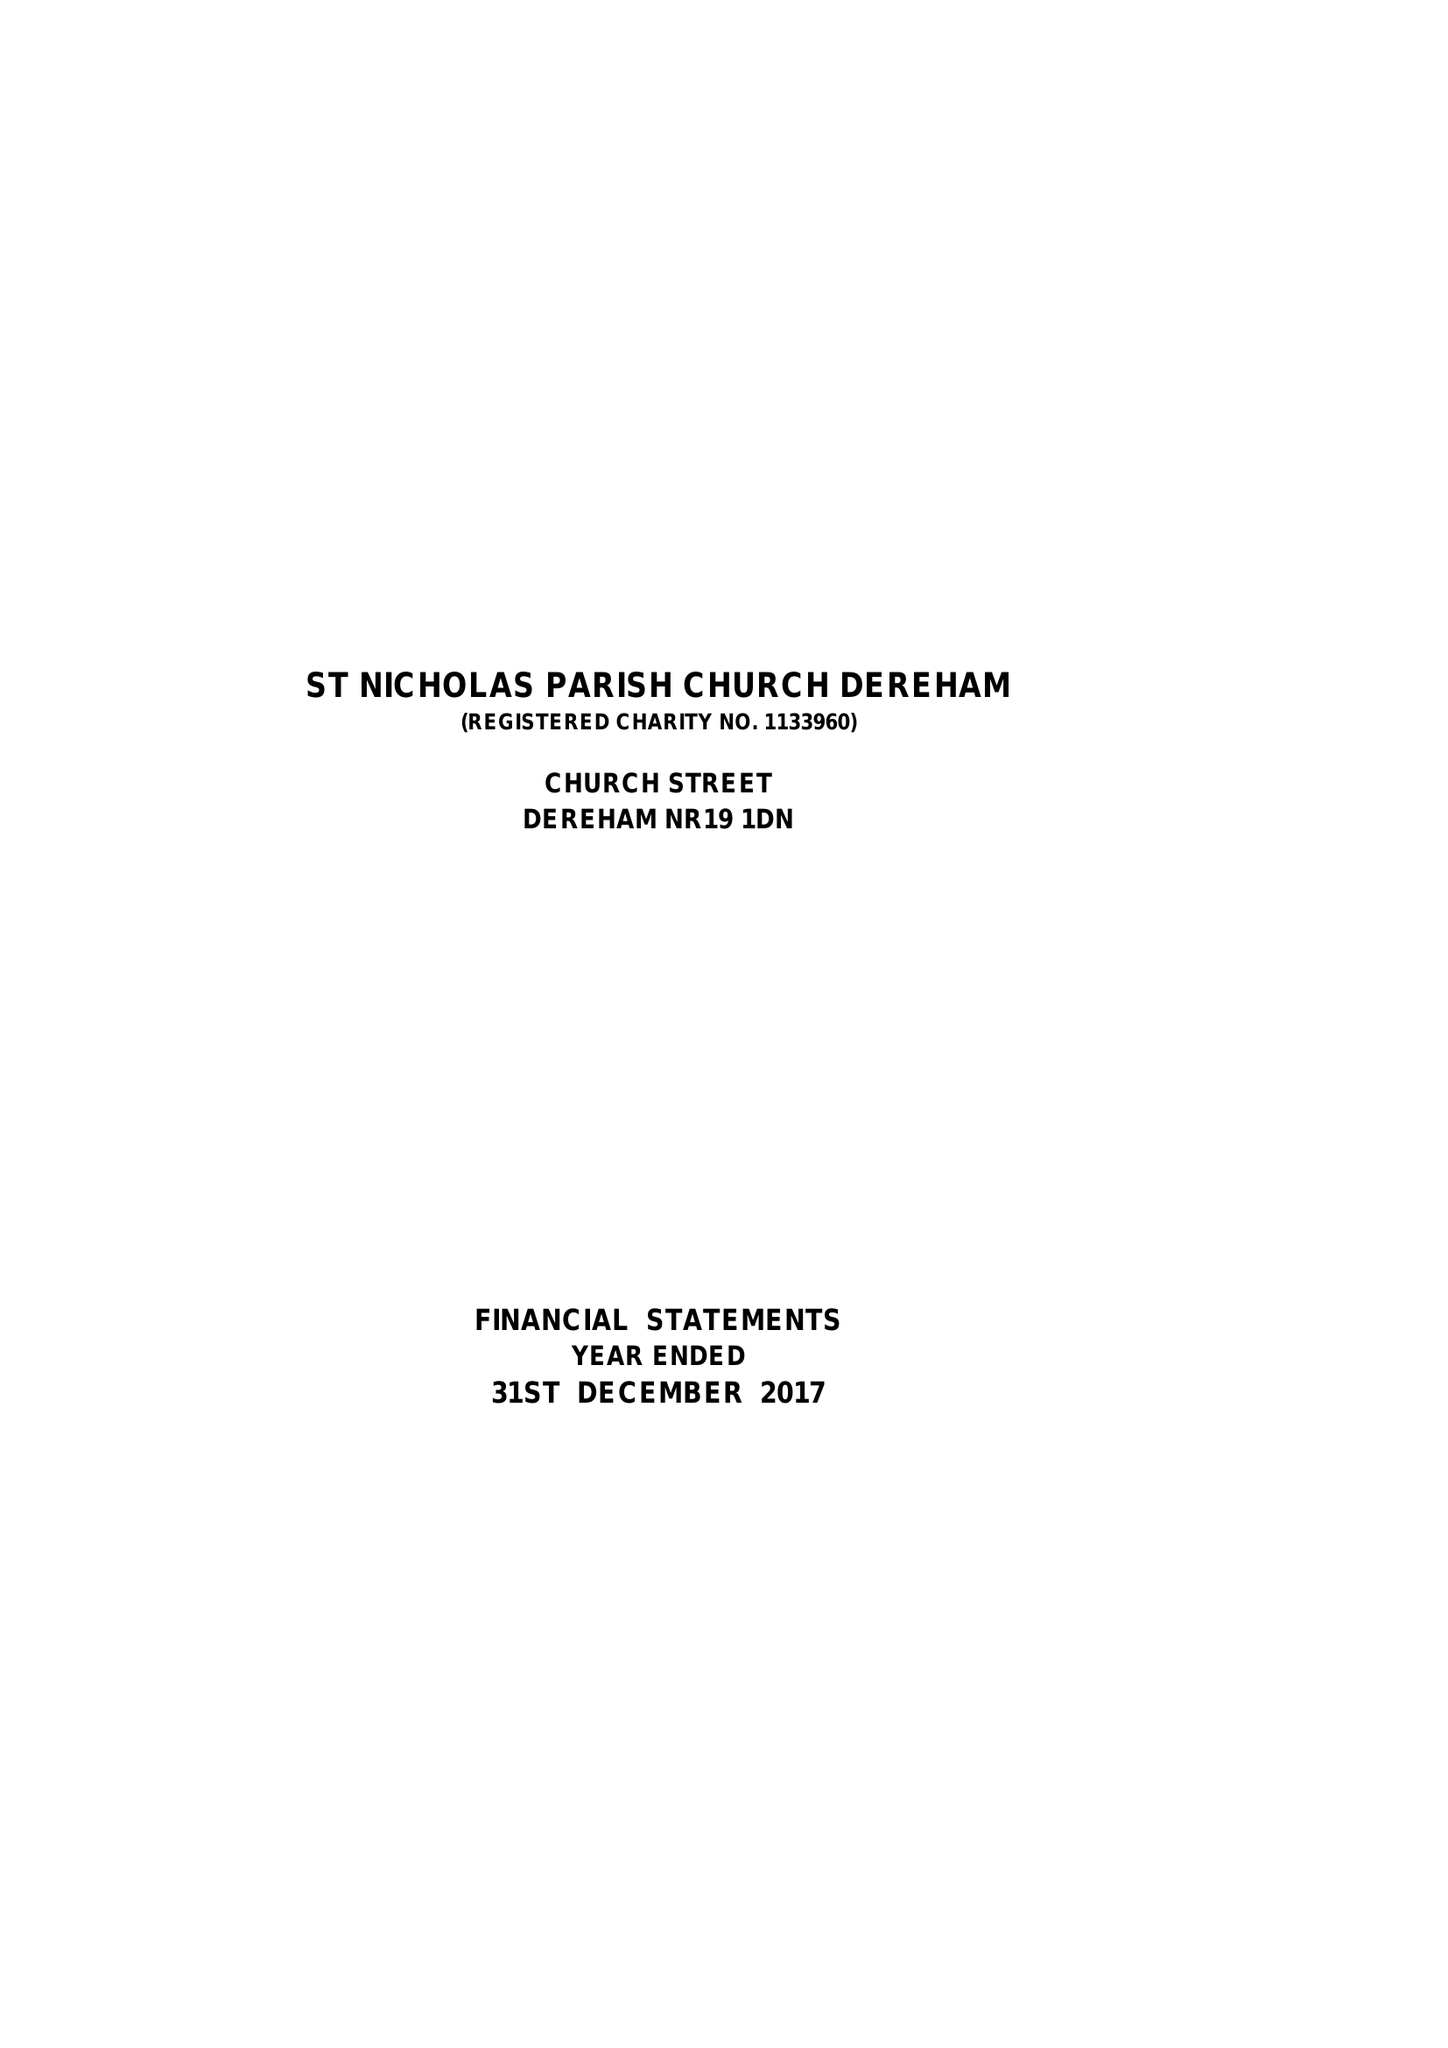What is the value for the address__street_line?
Answer the question using a single word or phrase. CHURCH STREET 